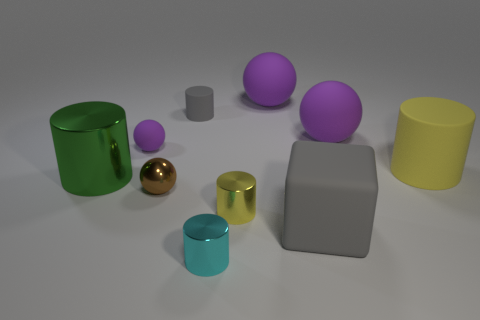What shape is the tiny thing behind the tiny purple rubber thing? The tiny object located behind the small purple sphere appears to be a cylinder, specifically a small cylindrical object with a metallic sheen, suggesting that it might be made of metal or a reflective material. 